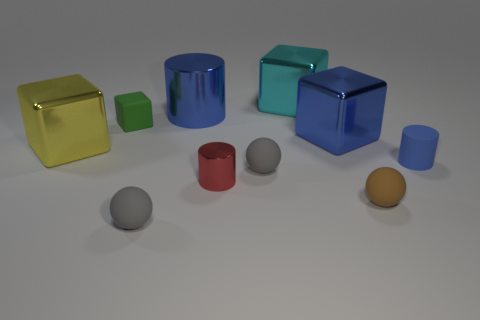Subtract all red cubes. Subtract all green cylinders. How many cubes are left? 4 Subtract all balls. How many objects are left? 7 Subtract 0 green spheres. How many objects are left? 10 Subtract all cylinders. Subtract all big shiny objects. How many objects are left? 3 Add 6 tiny rubber balls. How many tiny rubber balls are left? 9 Add 2 small gray matte objects. How many small gray matte objects exist? 4 